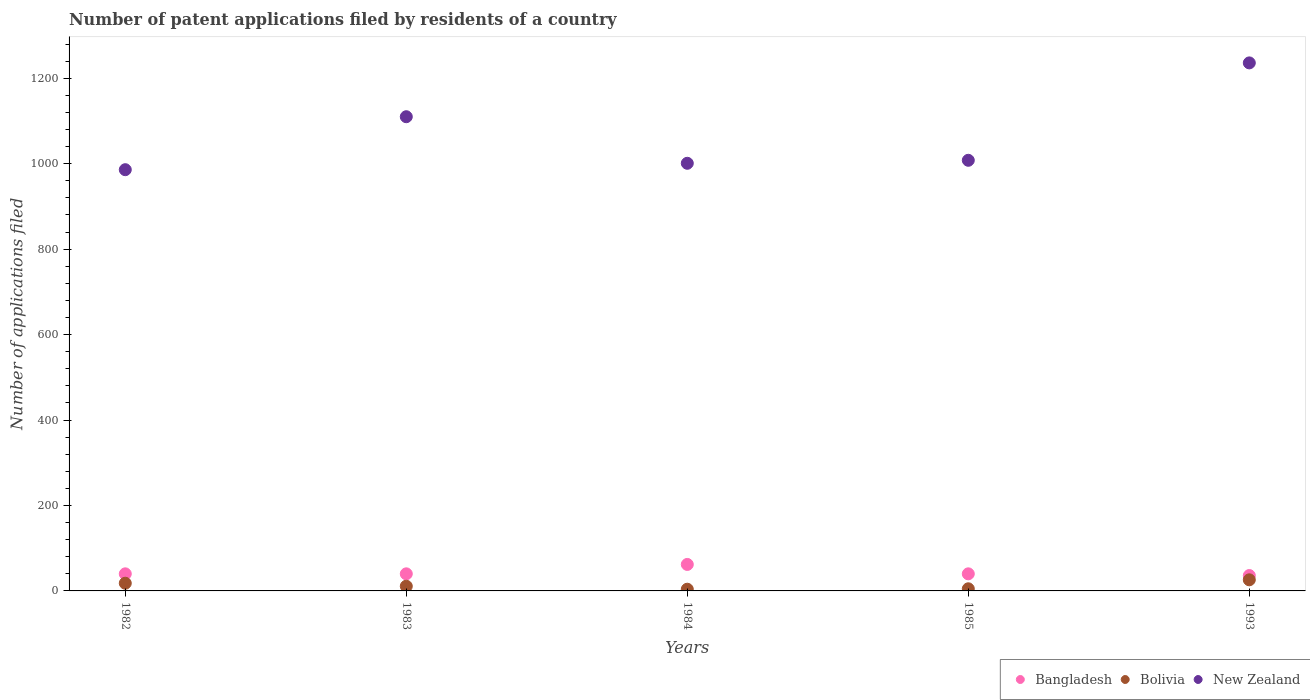Is the number of dotlines equal to the number of legend labels?
Give a very brief answer. Yes. What is the number of applications filed in New Zealand in 1984?
Ensure brevity in your answer.  1001. What is the total number of applications filed in Bangladesh in the graph?
Your answer should be very brief. 218. What is the difference between the number of applications filed in Bangladesh in 1983 and that in 1984?
Make the answer very short. -22. What is the difference between the number of applications filed in Bangladesh in 1993 and the number of applications filed in New Zealand in 1982?
Provide a succinct answer. -950. What is the average number of applications filed in New Zealand per year?
Offer a terse response. 1068.2. In the year 1993, what is the difference between the number of applications filed in Bolivia and number of applications filed in New Zealand?
Offer a terse response. -1210. In how many years, is the number of applications filed in Bolivia greater than 40?
Make the answer very short. 0. What is the ratio of the number of applications filed in New Zealand in 1983 to that in 1985?
Your answer should be very brief. 1.1. Is the number of applications filed in Bolivia in 1983 less than that in 1985?
Provide a succinct answer. No. Is the difference between the number of applications filed in Bolivia in 1982 and 1985 greater than the difference between the number of applications filed in New Zealand in 1982 and 1985?
Provide a succinct answer. Yes. What is the difference between the highest and the second highest number of applications filed in Bolivia?
Keep it short and to the point. 8. What is the difference between the highest and the lowest number of applications filed in New Zealand?
Ensure brevity in your answer.  250. In how many years, is the number of applications filed in Bolivia greater than the average number of applications filed in Bolivia taken over all years?
Provide a short and direct response. 2. Is the sum of the number of applications filed in New Zealand in 1982 and 1993 greater than the maximum number of applications filed in Bangladesh across all years?
Offer a terse response. Yes. Is it the case that in every year, the sum of the number of applications filed in New Zealand and number of applications filed in Bangladesh  is greater than the number of applications filed in Bolivia?
Make the answer very short. Yes. Is the number of applications filed in Bolivia strictly greater than the number of applications filed in Bangladesh over the years?
Keep it short and to the point. No. Is the number of applications filed in Bolivia strictly less than the number of applications filed in New Zealand over the years?
Provide a short and direct response. Yes. How many dotlines are there?
Provide a short and direct response. 3. Are the values on the major ticks of Y-axis written in scientific E-notation?
Offer a very short reply. No. Where does the legend appear in the graph?
Make the answer very short. Bottom right. How many legend labels are there?
Your answer should be compact. 3. What is the title of the graph?
Your answer should be compact. Number of patent applications filed by residents of a country. What is the label or title of the Y-axis?
Offer a very short reply. Number of applications filed. What is the Number of applications filed of Bangladesh in 1982?
Offer a terse response. 40. What is the Number of applications filed of New Zealand in 1982?
Keep it short and to the point. 986. What is the Number of applications filed of Bolivia in 1983?
Ensure brevity in your answer.  11. What is the Number of applications filed in New Zealand in 1983?
Offer a very short reply. 1110. What is the Number of applications filed in Bangladesh in 1984?
Offer a terse response. 62. What is the Number of applications filed in New Zealand in 1984?
Provide a short and direct response. 1001. What is the Number of applications filed in Bolivia in 1985?
Give a very brief answer. 5. What is the Number of applications filed in New Zealand in 1985?
Give a very brief answer. 1008. What is the Number of applications filed in Bangladesh in 1993?
Your response must be concise. 36. What is the Number of applications filed in New Zealand in 1993?
Offer a very short reply. 1236. Across all years, what is the maximum Number of applications filed in Bangladesh?
Provide a short and direct response. 62. Across all years, what is the maximum Number of applications filed of New Zealand?
Offer a terse response. 1236. Across all years, what is the minimum Number of applications filed in Bangladesh?
Your response must be concise. 36. Across all years, what is the minimum Number of applications filed of Bolivia?
Provide a short and direct response. 4. Across all years, what is the minimum Number of applications filed of New Zealand?
Offer a very short reply. 986. What is the total Number of applications filed in Bangladesh in the graph?
Keep it short and to the point. 218. What is the total Number of applications filed in New Zealand in the graph?
Offer a very short reply. 5341. What is the difference between the Number of applications filed of Bolivia in 1982 and that in 1983?
Your answer should be compact. 7. What is the difference between the Number of applications filed of New Zealand in 1982 and that in 1983?
Ensure brevity in your answer.  -124. What is the difference between the Number of applications filed of Bangladesh in 1982 and that in 1984?
Give a very brief answer. -22. What is the difference between the Number of applications filed of New Zealand in 1982 and that in 1984?
Keep it short and to the point. -15. What is the difference between the Number of applications filed of Bolivia in 1982 and that in 1985?
Your response must be concise. 13. What is the difference between the Number of applications filed in New Zealand in 1982 and that in 1993?
Your response must be concise. -250. What is the difference between the Number of applications filed of Bolivia in 1983 and that in 1984?
Your answer should be compact. 7. What is the difference between the Number of applications filed of New Zealand in 1983 and that in 1984?
Your response must be concise. 109. What is the difference between the Number of applications filed in Bangladesh in 1983 and that in 1985?
Provide a short and direct response. 0. What is the difference between the Number of applications filed in New Zealand in 1983 and that in 1985?
Your response must be concise. 102. What is the difference between the Number of applications filed in Bangladesh in 1983 and that in 1993?
Your answer should be very brief. 4. What is the difference between the Number of applications filed of Bolivia in 1983 and that in 1993?
Keep it short and to the point. -15. What is the difference between the Number of applications filed of New Zealand in 1983 and that in 1993?
Provide a short and direct response. -126. What is the difference between the Number of applications filed in Bolivia in 1984 and that in 1985?
Give a very brief answer. -1. What is the difference between the Number of applications filed of New Zealand in 1984 and that in 1985?
Ensure brevity in your answer.  -7. What is the difference between the Number of applications filed of Bolivia in 1984 and that in 1993?
Offer a very short reply. -22. What is the difference between the Number of applications filed of New Zealand in 1984 and that in 1993?
Your answer should be very brief. -235. What is the difference between the Number of applications filed of Bangladesh in 1985 and that in 1993?
Keep it short and to the point. 4. What is the difference between the Number of applications filed of Bolivia in 1985 and that in 1993?
Your answer should be very brief. -21. What is the difference between the Number of applications filed in New Zealand in 1985 and that in 1993?
Keep it short and to the point. -228. What is the difference between the Number of applications filed of Bangladesh in 1982 and the Number of applications filed of Bolivia in 1983?
Your answer should be very brief. 29. What is the difference between the Number of applications filed in Bangladesh in 1982 and the Number of applications filed in New Zealand in 1983?
Provide a short and direct response. -1070. What is the difference between the Number of applications filed in Bolivia in 1982 and the Number of applications filed in New Zealand in 1983?
Offer a very short reply. -1092. What is the difference between the Number of applications filed of Bangladesh in 1982 and the Number of applications filed of Bolivia in 1984?
Offer a terse response. 36. What is the difference between the Number of applications filed in Bangladesh in 1982 and the Number of applications filed in New Zealand in 1984?
Your answer should be very brief. -961. What is the difference between the Number of applications filed of Bolivia in 1982 and the Number of applications filed of New Zealand in 1984?
Offer a very short reply. -983. What is the difference between the Number of applications filed of Bangladesh in 1982 and the Number of applications filed of Bolivia in 1985?
Offer a terse response. 35. What is the difference between the Number of applications filed of Bangladesh in 1982 and the Number of applications filed of New Zealand in 1985?
Provide a short and direct response. -968. What is the difference between the Number of applications filed in Bolivia in 1982 and the Number of applications filed in New Zealand in 1985?
Provide a succinct answer. -990. What is the difference between the Number of applications filed in Bangladesh in 1982 and the Number of applications filed in New Zealand in 1993?
Provide a short and direct response. -1196. What is the difference between the Number of applications filed in Bolivia in 1982 and the Number of applications filed in New Zealand in 1993?
Ensure brevity in your answer.  -1218. What is the difference between the Number of applications filed of Bangladesh in 1983 and the Number of applications filed of Bolivia in 1984?
Your answer should be very brief. 36. What is the difference between the Number of applications filed of Bangladesh in 1983 and the Number of applications filed of New Zealand in 1984?
Offer a very short reply. -961. What is the difference between the Number of applications filed in Bolivia in 1983 and the Number of applications filed in New Zealand in 1984?
Provide a succinct answer. -990. What is the difference between the Number of applications filed in Bangladesh in 1983 and the Number of applications filed in Bolivia in 1985?
Ensure brevity in your answer.  35. What is the difference between the Number of applications filed of Bangladesh in 1983 and the Number of applications filed of New Zealand in 1985?
Provide a succinct answer. -968. What is the difference between the Number of applications filed of Bolivia in 1983 and the Number of applications filed of New Zealand in 1985?
Your response must be concise. -997. What is the difference between the Number of applications filed of Bangladesh in 1983 and the Number of applications filed of Bolivia in 1993?
Give a very brief answer. 14. What is the difference between the Number of applications filed in Bangladesh in 1983 and the Number of applications filed in New Zealand in 1993?
Provide a succinct answer. -1196. What is the difference between the Number of applications filed in Bolivia in 1983 and the Number of applications filed in New Zealand in 1993?
Provide a succinct answer. -1225. What is the difference between the Number of applications filed in Bangladesh in 1984 and the Number of applications filed in Bolivia in 1985?
Give a very brief answer. 57. What is the difference between the Number of applications filed in Bangladesh in 1984 and the Number of applications filed in New Zealand in 1985?
Give a very brief answer. -946. What is the difference between the Number of applications filed in Bolivia in 1984 and the Number of applications filed in New Zealand in 1985?
Your answer should be very brief. -1004. What is the difference between the Number of applications filed of Bangladesh in 1984 and the Number of applications filed of Bolivia in 1993?
Make the answer very short. 36. What is the difference between the Number of applications filed in Bangladesh in 1984 and the Number of applications filed in New Zealand in 1993?
Ensure brevity in your answer.  -1174. What is the difference between the Number of applications filed in Bolivia in 1984 and the Number of applications filed in New Zealand in 1993?
Your answer should be very brief. -1232. What is the difference between the Number of applications filed in Bangladesh in 1985 and the Number of applications filed in New Zealand in 1993?
Offer a very short reply. -1196. What is the difference between the Number of applications filed of Bolivia in 1985 and the Number of applications filed of New Zealand in 1993?
Provide a succinct answer. -1231. What is the average Number of applications filed of Bangladesh per year?
Offer a terse response. 43.6. What is the average Number of applications filed of Bolivia per year?
Provide a succinct answer. 12.8. What is the average Number of applications filed of New Zealand per year?
Give a very brief answer. 1068.2. In the year 1982, what is the difference between the Number of applications filed in Bangladesh and Number of applications filed in Bolivia?
Provide a succinct answer. 22. In the year 1982, what is the difference between the Number of applications filed in Bangladesh and Number of applications filed in New Zealand?
Provide a short and direct response. -946. In the year 1982, what is the difference between the Number of applications filed of Bolivia and Number of applications filed of New Zealand?
Ensure brevity in your answer.  -968. In the year 1983, what is the difference between the Number of applications filed in Bangladesh and Number of applications filed in New Zealand?
Ensure brevity in your answer.  -1070. In the year 1983, what is the difference between the Number of applications filed in Bolivia and Number of applications filed in New Zealand?
Offer a very short reply. -1099. In the year 1984, what is the difference between the Number of applications filed of Bangladesh and Number of applications filed of New Zealand?
Keep it short and to the point. -939. In the year 1984, what is the difference between the Number of applications filed of Bolivia and Number of applications filed of New Zealand?
Give a very brief answer. -997. In the year 1985, what is the difference between the Number of applications filed of Bangladesh and Number of applications filed of New Zealand?
Make the answer very short. -968. In the year 1985, what is the difference between the Number of applications filed of Bolivia and Number of applications filed of New Zealand?
Provide a short and direct response. -1003. In the year 1993, what is the difference between the Number of applications filed in Bangladesh and Number of applications filed in Bolivia?
Provide a short and direct response. 10. In the year 1993, what is the difference between the Number of applications filed in Bangladesh and Number of applications filed in New Zealand?
Provide a succinct answer. -1200. In the year 1993, what is the difference between the Number of applications filed in Bolivia and Number of applications filed in New Zealand?
Offer a very short reply. -1210. What is the ratio of the Number of applications filed of Bolivia in 1982 to that in 1983?
Your answer should be compact. 1.64. What is the ratio of the Number of applications filed in New Zealand in 1982 to that in 1983?
Your answer should be very brief. 0.89. What is the ratio of the Number of applications filed of Bangladesh in 1982 to that in 1984?
Make the answer very short. 0.65. What is the ratio of the Number of applications filed of New Zealand in 1982 to that in 1984?
Give a very brief answer. 0.98. What is the ratio of the Number of applications filed in Bangladesh in 1982 to that in 1985?
Offer a terse response. 1. What is the ratio of the Number of applications filed of Bolivia in 1982 to that in 1985?
Keep it short and to the point. 3.6. What is the ratio of the Number of applications filed in New Zealand in 1982 to that in 1985?
Keep it short and to the point. 0.98. What is the ratio of the Number of applications filed in Bangladesh in 1982 to that in 1993?
Offer a very short reply. 1.11. What is the ratio of the Number of applications filed in Bolivia in 1982 to that in 1993?
Your answer should be compact. 0.69. What is the ratio of the Number of applications filed of New Zealand in 1982 to that in 1993?
Your response must be concise. 0.8. What is the ratio of the Number of applications filed of Bangladesh in 1983 to that in 1984?
Keep it short and to the point. 0.65. What is the ratio of the Number of applications filed in Bolivia in 1983 to that in 1984?
Offer a terse response. 2.75. What is the ratio of the Number of applications filed of New Zealand in 1983 to that in 1984?
Your response must be concise. 1.11. What is the ratio of the Number of applications filed of New Zealand in 1983 to that in 1985?
Your answer should be compact. 1.1. What is the ratio of the Number of applications filed in Bolivia in 1983 to that in 1993?
Keep it short and to the point. 0.42. What is the ratio of the Number of applications filed in New Zealand in 1983 to that in 1993?
Keep it short and to the point. 0.9. What is the ratio of the Number of applications filed in Bangladesh in 1984 to that in 1985?
Offer a terse response. 1.55. What is the ratio of the Number of applications filed of Bolivia in 1984 to that in 1985?
Offer a terse response. 0.8. What is the ratio of the Number of applications filed of Bangladesh in 1984 to that in 1993?
Ensure brevity in your answer.  1.72. What is the ratio of the Number of applications filed in Bolivia in 1984 to that in 1993?
Offer a very short reply. 0.15. What is the ratio of the Number of applications filed of New Zealand in 1984 to that in 1993?
Your answer should be very brief. 0.81. What is the ratio of the Number of applications filed in Bangladesh in 1985 to that in 1993?
Provide a short and direct response. 1.11. What is the ratio of the Number of applications filed of Bolivia in 1985 to that in 1993?
Keep it short and to the point. 0.19. What is the ratio of the Number of applications filed of New Zealand in 1985 to that in 1993?
Your answer should be compact. 0.82. What is the difference between the highest and the second highest Number of applications filed of Bangladesh?
Provide a succinct answer. 22. What is the difference between the highest and the second highest Number of applications filed of New Zealand?
Your response must be concise. 126. What is the difference between the highest and the lowest Number of applications filed in Bangladesh?
Make the answer very short. 26. What is the difference between the highest and the lowest Number of applications filed of Bolivia?
Make the answer very short. 22. What is the difference between the highest and the lowest Number of applications filed of New Zealand?
Your answer should be compact. 250. 